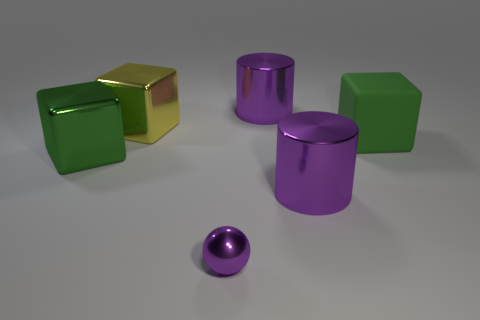Add 2 small yellow matte objects. How many objects exist? 8 Subtract all metal cubes. How many cubes are left? 1 Subtract all cylinders. How many objects are left? 4 Add 1 small yellow shiny cubes. How many small yellow shiny cubes exist? 1 Subtract all yellow blocks. How many blocks are left? 2 Subtract 1 yellow blocks. How many objects are left? 5 Subtract 1 balls. How many balls are left? 0 Subtract all blue balls. Subtract all yellow blocks. How many balls are left? 1 Subtract all yellow cylinders. How many yellow blocks are left? 1 Subtract all green objects. Subtract all purple metal cylinders. How many objects are left? 2 